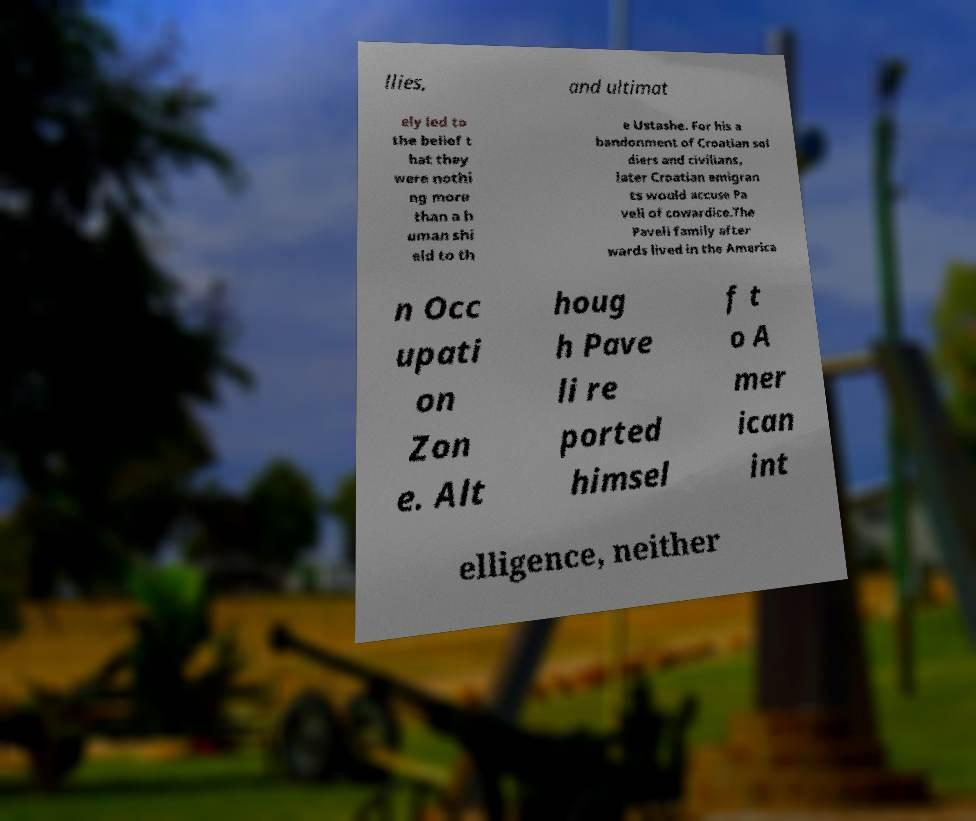Can you read and provide the text displayed in the image?This photo seems to have some interesting text. Can you extract and type it out for me? llies, and ultimat ely led to the belief t hat they were nothi ng more than a h uman shi eld to th e Ustashe. For his a bandonment of Croatian sol diers and civilians, later Croatian emigran ts would accuse Pa veli of cowardice.The Paveli family after wards lived in the America n Occ upati on Zon e. Alt houg h Pave li re ported himsel f t o A mer ican int elligence, neither 